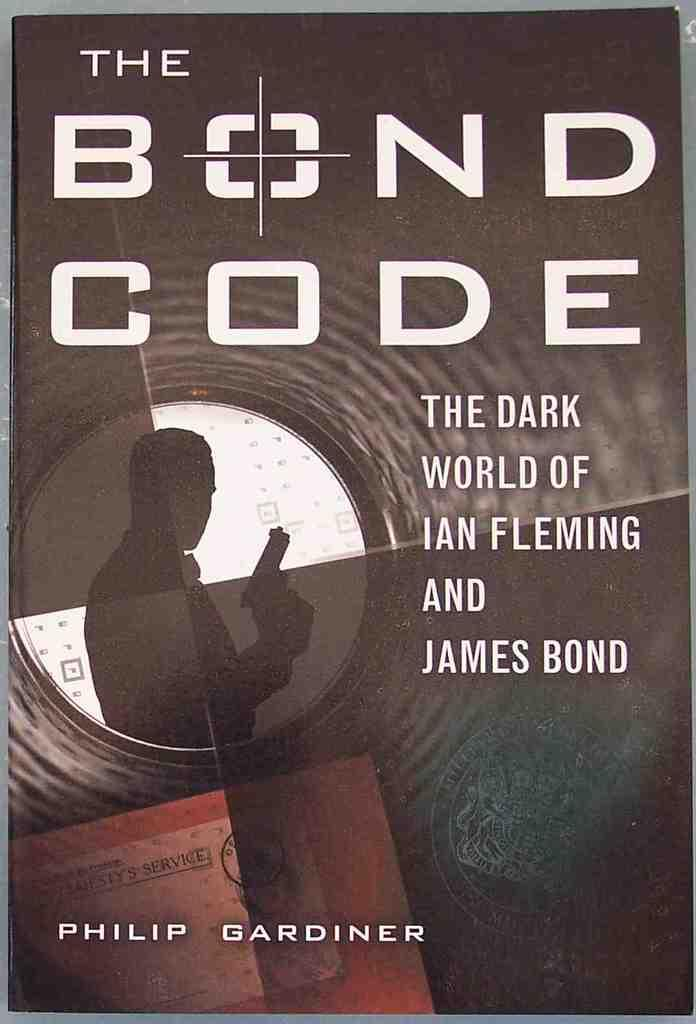What is the main subject of the image? There is a depiction of a person in the image. Are there any words or letters in the image? Yes, there is some text in the image. What type of bird is singing a verse in the image? There is no bird or singing in the image; it features a depiction of a person and some text. 